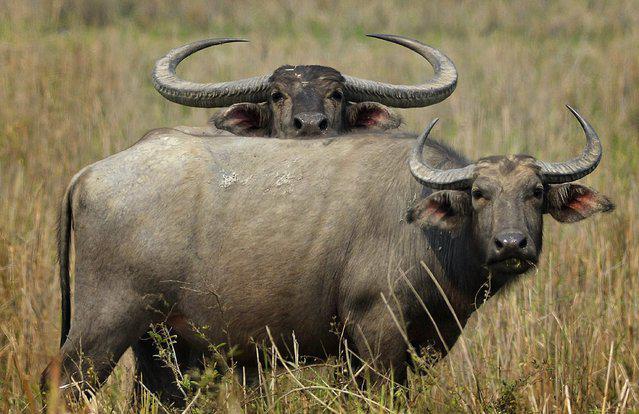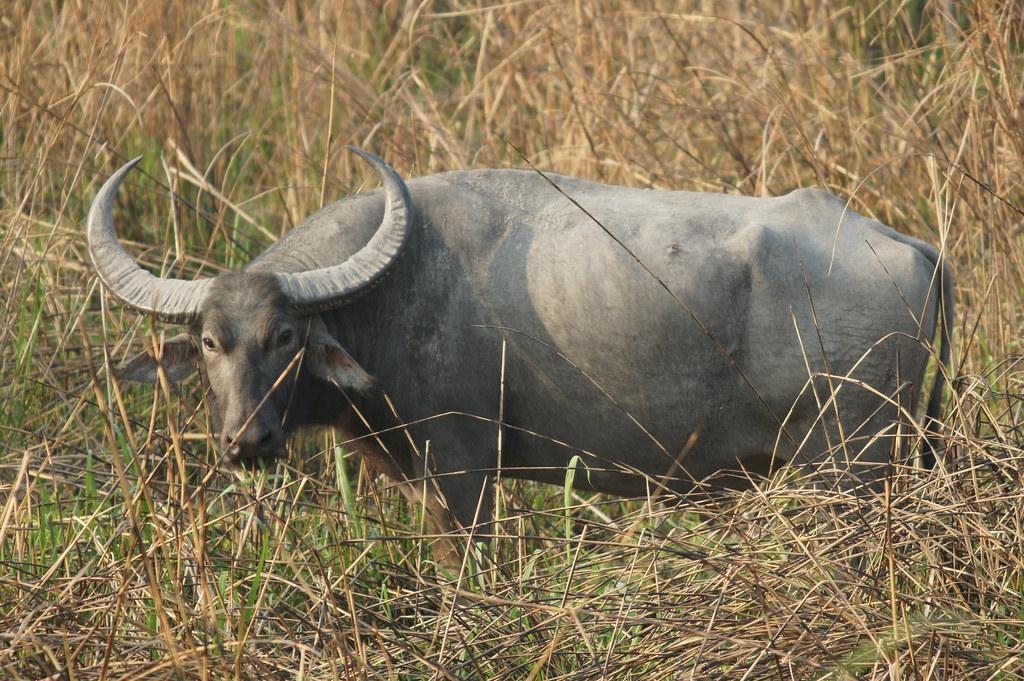The first image is the image on the left, the second image is the image on the right. For the images displayed, is the sentence "One of the images contains at least three water buffalo." factually correct? Answer yes or no. No. The first image is the image on the left, the second image is the image on the right. Evaluate the accuracy of this statement regarding the images: "There is exactly one animal in the image on the right.". Is it true? Answer yes or no. Yes. 